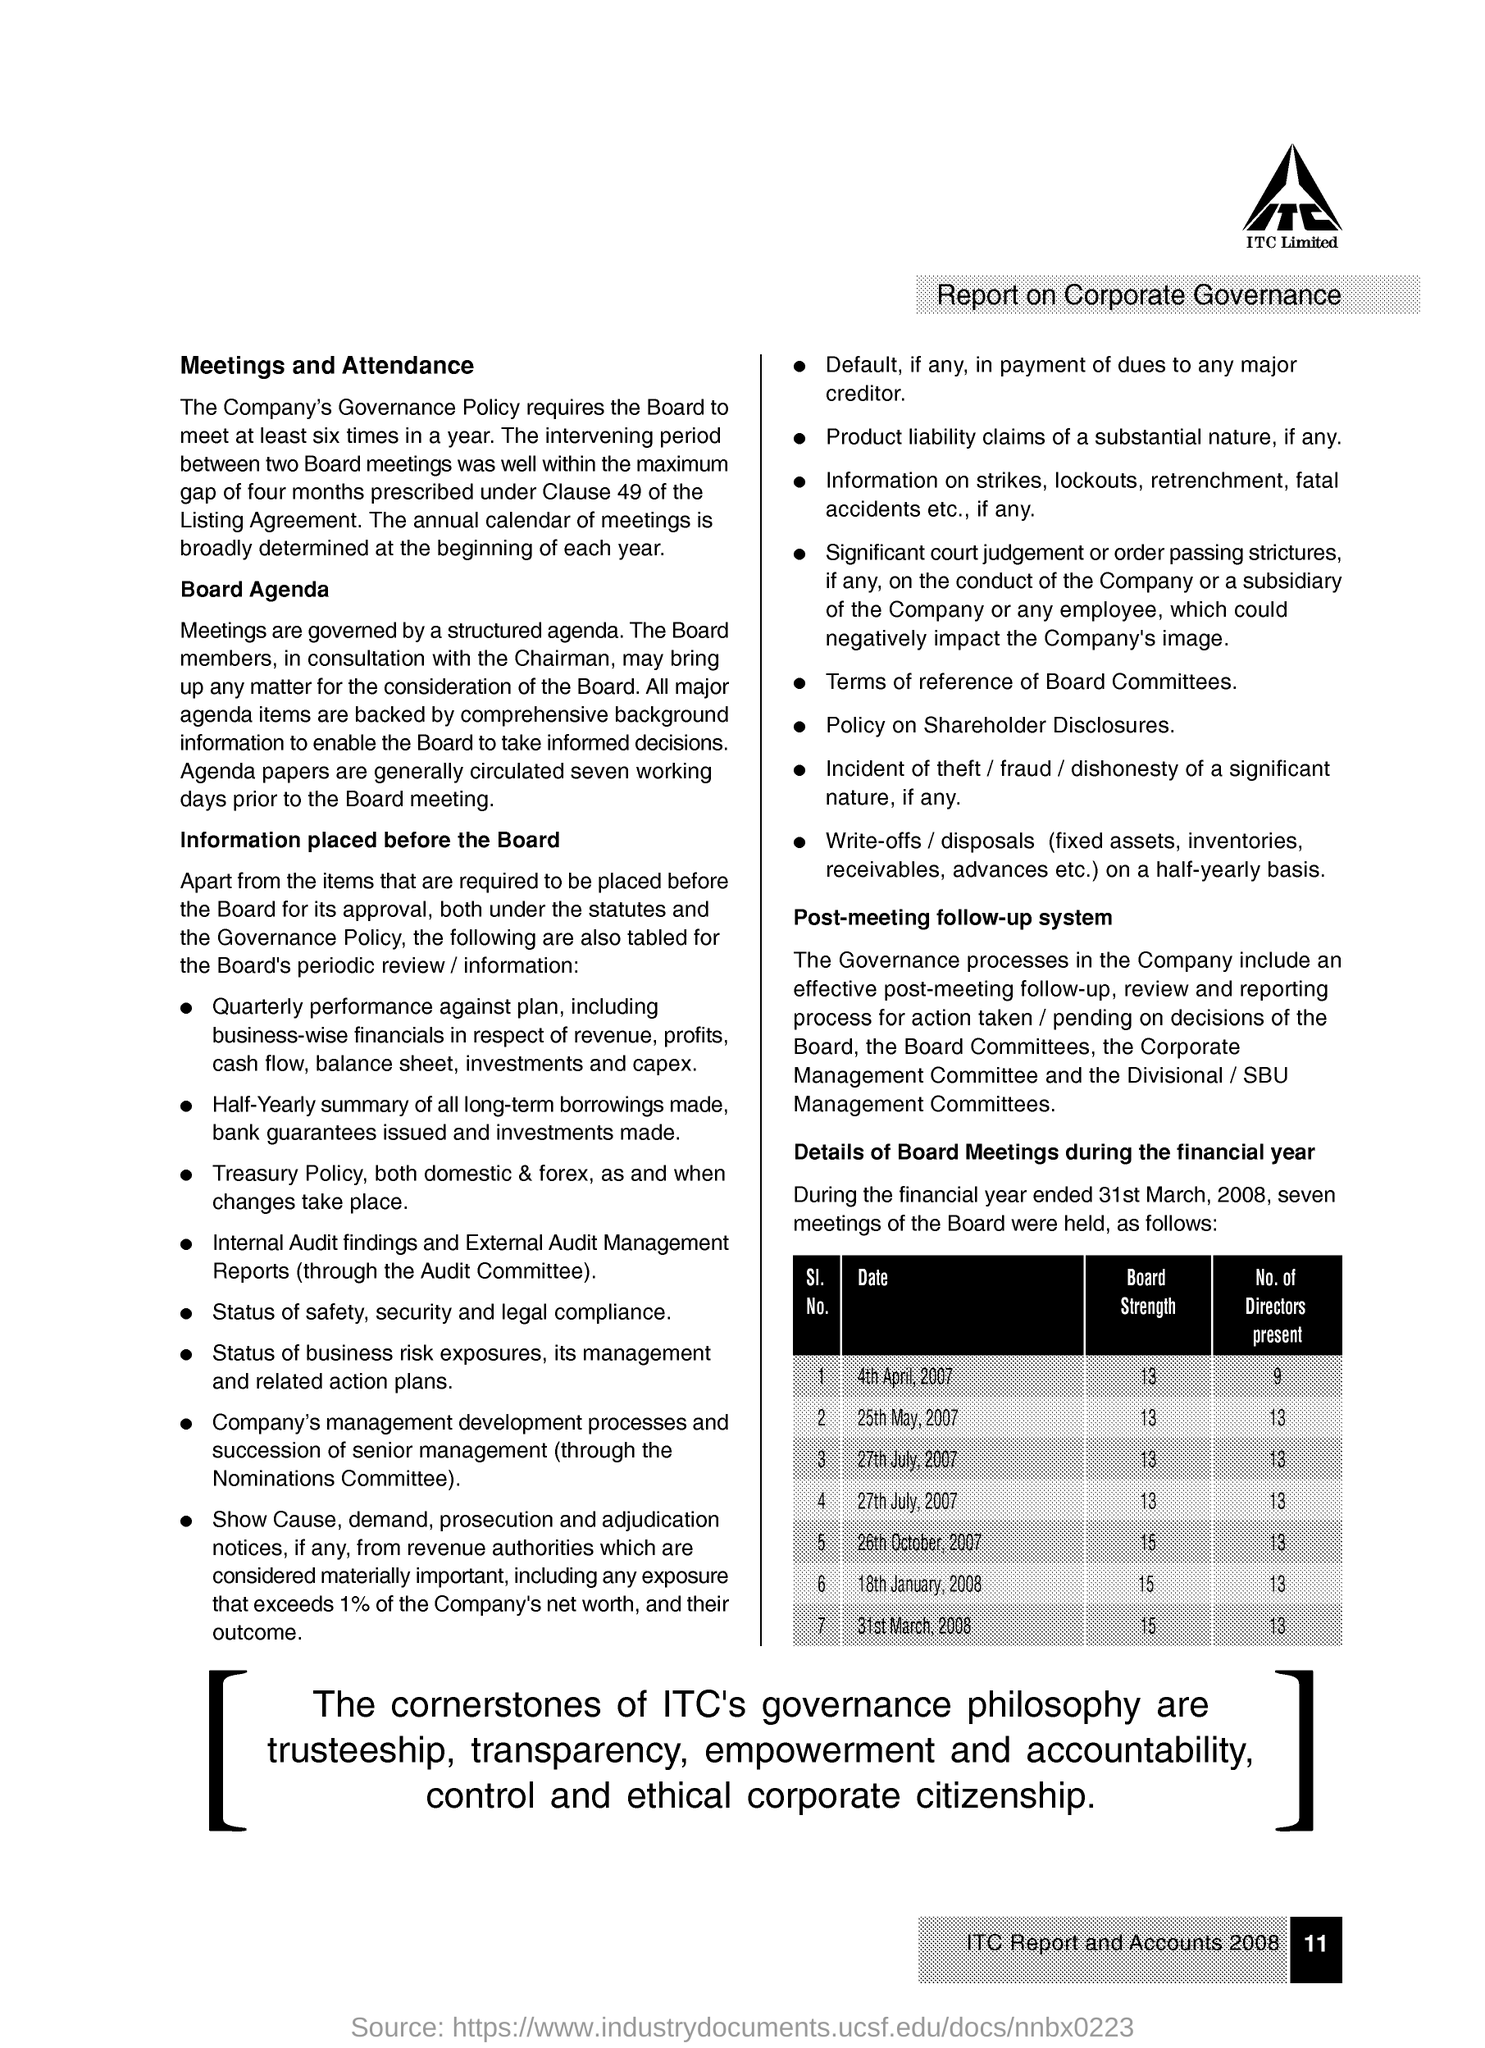What is the Board Strength for Date 4th April, 2007?
Your response must be concise. 13. What is the Board Strength for Date 25th May, 2007?
Your answer should be very brief. 13. What is the Board Strength for Date 27th July, 2007?
Keep it short and to the point. 13. What is the Board Strength for Date 26th October, 2007?
Offer a terse response. 15. What is the Board Strength for Date 18th January, 2008?
Provide a short and direct response. 15. What is the Board Strength for Date 31st March, 2008?
Provide a short and direct response. 15. What is the No. of Directors present for Date 4th April, 2007?
Make the answer very short. 9. What is the No. of Directors present for Date 25th May, 2007?
Your answer should be compact. 13. What is the No. of Directors present for Date 26th October, 2007?
Offer a very short reply. 13. What is the No. of Directors present for Date 18th January, 2008?
Offer a very short reply. 13. 